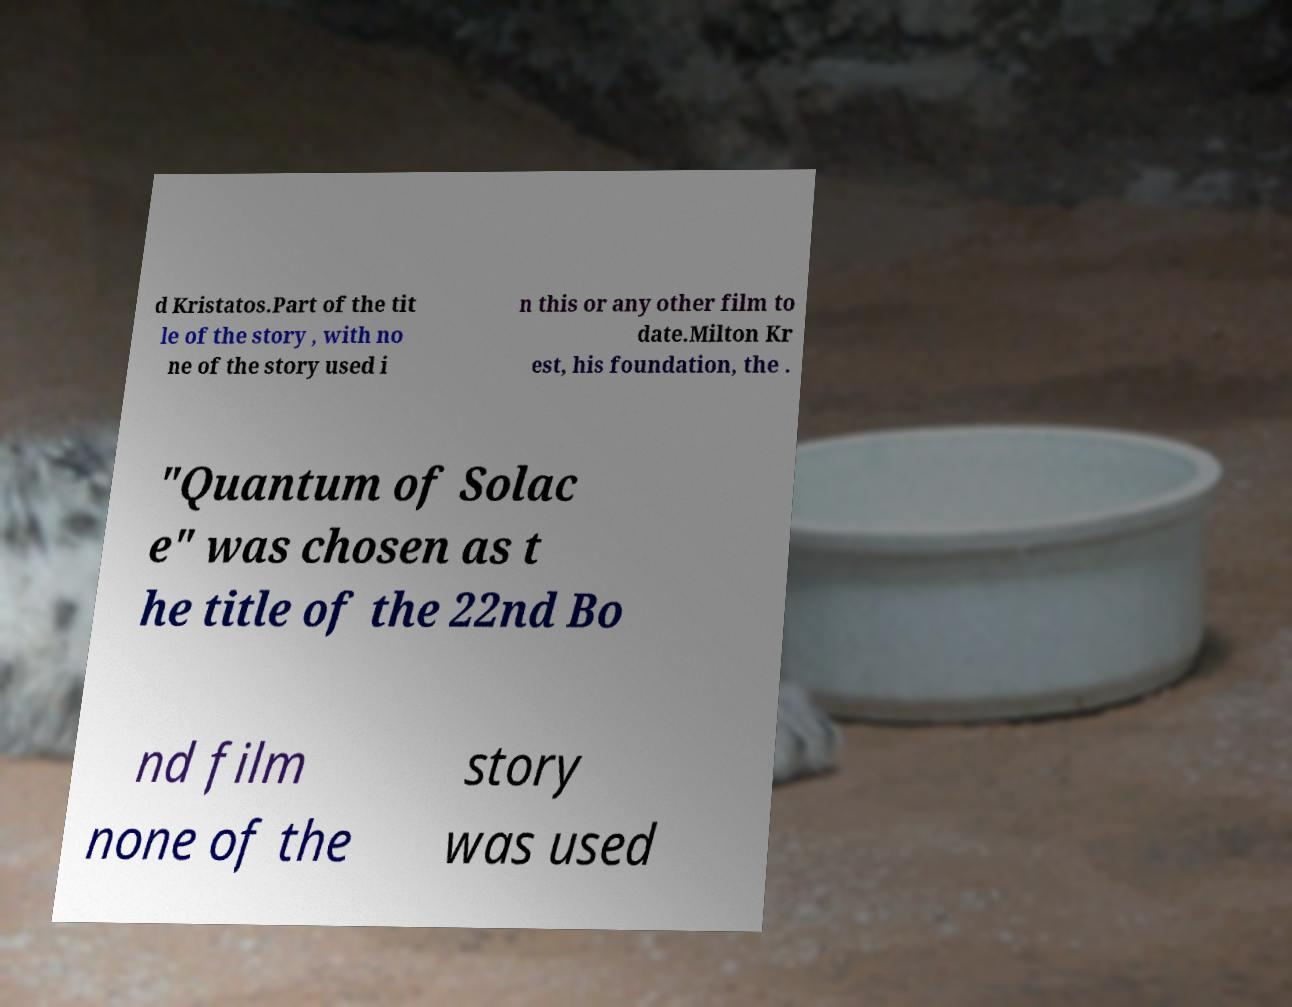Can you accurately transcribe the text from the provided image for me? d Kristatos.Part of the tit le of the story , with no ne of the story used i n this or any other film to date.Milton Kr est, his foundation, the . "Quantum of Solac e" was chosen as t he title of the 22nd Bo nd film none of the story was used 